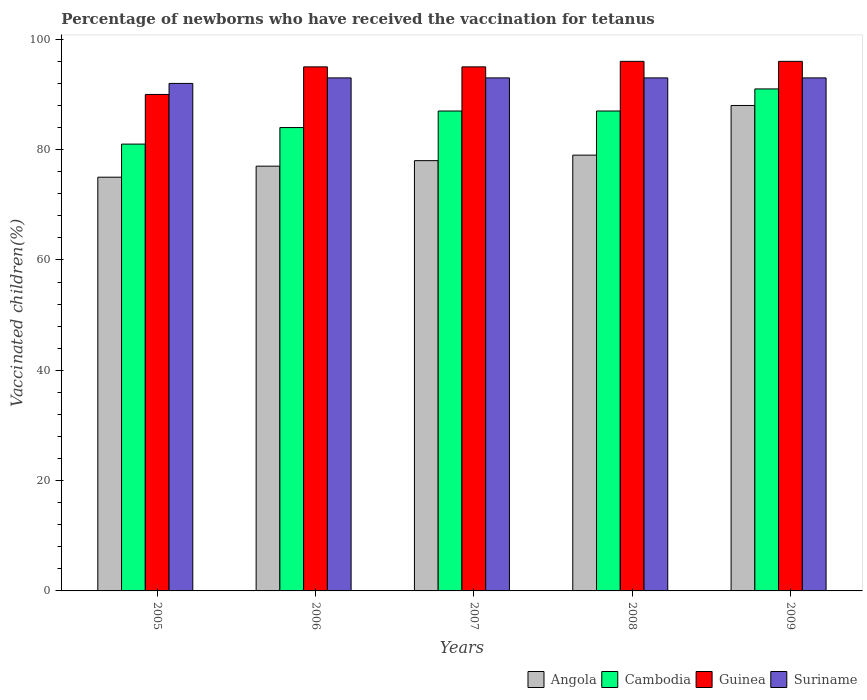Are the number of bars on each tick of the X-axis equal?
Offer a very short reply. Yes. How many bars are there on the 1st tick from the left?
Provide a succinct answer. 4. How many bars are there on the 1st tick from the right?
Offer a very short reply. 4. Across all years, what is the maximum percentage of vaccinated children in Cambodia?
Keep it short and to the point. 91. Across all years, what is the minimum percentage of vaccinated children in Angola?
Your response must be concise. 75. What is the total percentage of vaccinated children in Guinea in the graph?
Provide a short and direct response. 472. What is the difference between the percentage of vaccinated children in Suriname in 2006 and that in 2008?
Provide a short and direct response. 0. What is the average percentage of vaccinated children in Angola per year?
Offer a terse response. 79.4. In how many years, is the percentage of vaccinated children in Angola greater than 68 %?
Keep it short and to the point. 5. What is the ratio of the percentage of vaccinated children in Angola in 2006 to that in 2008?
Offer a very short reply. 0.97. Is the percentage of vaccinated children in Guinea in 2006 less than that in 2007?
Your answer should be very brief. No. Is the difference between the percentage of vaccinated children in Cambodia in 2006 and 2007 greater than the difference between the percentage of vaccinated children in Suriname in 2006 and 2007?
Make the answer very short. No. What is the difference between the highest and the second highest percentage of vaccinated children in Guinea?
Give a very brief answer. 0. Is the sum of the percentage of vaccinated children in Angola in 2005 and 2007 greater than the maximum percentage of vaccinated children in Suriname across all years?
Offer a very short reply. Yes. What does the 1st bar from the left in 2008 represents?
Offer a terse response. Angola. What does the 3rd bar from the right in 2008 represents?
Your response must be concise. Cambodia. Is it the case that in every year, the sum of the percentage of vaccinated children in Cambodia and percentage of vaccinated children in Guinea is greater than the percentage of vaccinated children in Suriname?
Your response must be concise. Yes. How many bars are there?
Provide a short and direct response. 20. Are all the bars in the graph horizontal?
Keep it short and to the point. No. What is the difference between two consecutive major ticks on the Y-axis?
Offer a terse response. 20. Are the values on the major ticks of Y-axis written in scientific E-notation?
Ensure brevity in your answer.  No. Does the graph contain any zero values?
Offer a very short reply. No. How are the legend labels stacked?
Your response must be concise. Horizontal. What is the title of the graph?
Provide a short and direct response. Percentage of newborns who have received the vaccination for tetanus. What is the label or title of the X-axis?
Ensure brevity in your answer.  Years. What is the label or title of the Y-axis?
Give a very brief answer. Vaccinated children(%). What is the Vaccinated children(%) in Cambodia in 2005?
Provide a succinct answer. 81. What is the Vaccinated children(%) in Guinea in 2005?
Offer a terse response. 90. What is the Vaccinated children(%) of Suriname in 2005?
Your answer should be compact. 92. What is the Vaccinated children(%) in Suriname in 2006?
Make the answer very short. 93. What is the Vaccinated children(%) of Angola in 2007?
Make the answer very short. 78. What is the Vaccinated children(%) in Guinea in 2007?
Your answer should be compact. 95. What is the Vaccinated children(%) in Suriname in 2007?
Provide a short and direct response. 93. What is the Vaccinated children(%) in Angola in 2008?
Provide a short and direct response. 79. What is the Vaccinated children(%) in Cambodia in 2008?
Give a very brief answer. 87. What is the Vaccinated children(%) in Guinea in 2008?
Your answer should be compact. 96. What is the Vaccinated children(%) of Suriname in 2008?
Ensure brevity in your answer.  93. What is the Vaccinated children(%) in Cambodia in 2009?
Provide a succinct answer. 91. What is the Vaccinated children(%) of Guinea in 2009?
Your response must be concise. 96. What is the Vaccinated children(%) in Suriname in 2009?
Provide a succinct answer. 93. Across all years, what is the maximum Vaccinated children(%) in Cambodia?
Provide a succinct answer. 91. Across all years, what is the maximum Vaccinated children(%) of Guinea?
Ensure brevity in your answer.  96. Across all years, what is the maximum Vaccinated children(%) of Suriname?
Provide a short and direct response. 93. Across all years, what is the minimum Vaccinated children(%) of Angola?
Provide a short and direct response. 75. Across all years, what is the minimum Vaccinated children(%) in Cambodia?
Give a very brief answer. 81. Across all years, what is the minimum Vaccinated children(%) of Guinea?
Keep it short and to the point. 90. Across all years, what is the minimum Vaccinated children(%) of Suriname?
Offer a terse response. 92. What is the total Vaccinated children(%) in Angola in the graph?
Give a very brief answer. 397. What is the total Vaccinated children(%) of Cambodia in the graph?
Offer a very short reply. 430. What is the total Vaccinated children(%) in Guinea in the graph?
Keep it short and to the point. 472. What is the total Vaccinated children(%) of Suriname in the graph?
Provide a short and direct response. 464. What is the difference between the Vaccinated children(%) in Angola in 2005 and that in 2006?
Your answer should be compact. -2. What is the difference between the Vaccinated children(%) in Cambodia in 2005 and that in 2006?
Your response must be concise. -3. What is the difference between the Vaccinated children(%) of Cambodia in 2005 and that in 2007?
Offer a terse response. -6. What is the difference between the Vaccinated children(%) of Suriname in 2005 and that in 2007?
Make the answer very short. -1. What is the difference between the Vaccinated children(%) of Cambodia in 2005 and that in 2009?
Your answer should be very brief. -10. What is the difference between the Vaccinated children(%) of Suriname in 2005 and that in 2009?
Your answer should be compact. -1. What is the difference between the Vaccinated children(%) of Angola in 2006 and that in 2007?
Your answer should be very brief. -1. What is the difference between the Vaccinated children(%) in Cambodia in 2006 and that in 2007?
Your answer should be compact. -3. What is the difference between the Vaccinated children(%) in Guinea in 2006 and that in 2007?
Keep it short and to the point. 0. What is the difference between the Vaccinated children(%) in Suriname in 2006 and that in 2007?
Ensure brevity in your answer.  0. What is the difference between the Vaccinated children(%) of Angola in 2006 and that in 2008?
Keep it short and to the point. -2. What is the difference between the Vaccinated children(%) of Angola in 2006 and that in 2009?
Keep it short and to the point. -11. What is the difference between the Vaccinated children(%) in Cambodia in 2006 and that in 2009?
Your answer should be very brief. -7. What is the difference between the Vaccinated children(%) of Guinea in 2006 and that in 2009?
Provide a short and direct response. -1. What is the difference between the Vaccinated children(%) of Angola in 2007 and that in 2008?
Ensure brevity in your answer.  -1. What is the difference between the Vaccinated children(%) of Cambodia in 2007 and that in 2009?
Your answer should be very brief. -4. What is the difference between the Vaccinated children(%) of Angola in 2008 and that in 2009?
Offer a very short reply. -9. What is the difference between the Vaccinated children(%) in Cambodia in 2008 and that in 2009?
Provide a succinct answer. -4. What is the difference between the Vaccinated children(%) of Angola in 2005 and the Vaccinated children(%) of Suriname in 2006?
Your response must be concise. -18. What is the difference between the Vaccinated children(%) of Cambodia in 2005 and the Vaccinated children(%) of Suriname in 2006?
Provide a succinct answer. -12. What is the difference between the Vaccinated children(%) of Angola in 2005 and the Vaccinated children(%) of Suriname in 2007?
Provide a succinct answer. -18. What is the difference between the Vaccinated children(%) of Cambodia in 2005 and the Vaccinated children(%) of Guinea in 2007?
Provide a short and direct response. -14. What is the difference between the Vaccinated children(%) of Cambodia in 2005 and the Vaccinated children(%) of Suriname in 2007?
Your answer should be very brief. -12. What is the difference between the Vaccinated children(%) of Guinea in 2005 and the Vaccinated children(%) of Suriname in 2007?
Keep it short and to the point. -3. What is the difference between the Vaccinated children(%) in Angola in 2005 and the Vaccinated children(%) in Guinea in 2008?
Provide a short and direct response. -21. What is the difference between the Vaccinated children(%) of Angola in 2005 and the Vaccinated children(%) of Suriname in 2008?
Make the answer very short. -18. What is the difference between the Vaccinated children(%) in Guinea in 2005 and the Vaccinated children(%) in Suriname in 2008?
Your answer should be compact. -3. What is the difference between the Vaccinated children(%) in Angola in 2005 and the Vaccinated children(%) in Cambodia in 2009?
Your response must be concise. -16. What is the difference between the Vaccinated children(%) of Cambodia in 2005 and the Vaccinated children(%) of Suriname in 2009?
Your answer should be compact. -12. What is the difference between the Vaccinated children(%) in Angola in 2006 and the Vaccinated children(%) in Guinea in 2007?
Your response must be concise. -18. What is the difference between the Vaccinated children(%) of Angola in 2006 and the Vaccinated children(%) of Suriname in 2007?
Your answer should be very brief. -16. What is the difference between the Vaccinated children(%) in Cambodia in 2006 and the Vaccinated children(%) in Guinea in 2007?
Provide a short and direct response. -11. What is the difference between the Vaccinated children(%) of Guinea in 2006 and the Vaccinated children(%) of Suriname in 2007?
Your answer should be very brief. 2. What is the difference between the Vaccinated children(%) of Angola in 2006 and the Vaccinated children(%) of Guinea in 2008?
Provide a succinct answer. -19. What is the difference between the Vaccinated children(%) of Cambodia in 2006 and the Vaccinated children(%) of Guinea in 2008?
Make the answer very short. -12. What is the difference between the Vaccinated children(%) of Angola in 2006 and the Vaccinated children(%) of Cambodia in 2009?
Provide a succinct answer. -14. What is the difference between the Vaccinated children(%) of Angola in 2006 and the Vaccinated children(%) of Suriname in 2009?
Keep it short and to the point. -16. What is the difference between the Vaccinated children(%) of Cambodia in 2006 and the Vaccinated children(%) of Guinea in 2009?
Ensure brevity in your answer.  -12. What is the difference between the Vaccinated children(%) in Guinea in 2006 and the Vaccinated children(%) in Suriname in 2009?
Offer a terse response. 2. What is the difference between the Vaccinated children(%) of Angola in 2007 and the Vaccinated children(%) of Suriname in 2008?
Keep it short and to the point. -15. What is the difference between the Vaccinated children(%) of Cambodia in 2007 and the Vaccinated children(%) of Guinea in 2008?
Offer a very short reply. -9. What is the difference between the Vaccinated children(%) of Angola in 2007 and the Vaccinated children(%) of Suriname in 2009?
Ensure brevity in your answer.  -15. What is the difference between the Vaccinated children(%) of Cambodia in 2007 and the Vaccinated children(%) of Suriname in 2009?
Your answer should be very brief. -6. What is the difference between the Vaccinated children(%) of Angola in 2008 and the Vaccinated children(%) of Cambodia in 2009?
Offer a very short reply. -12. What is the difference between the Vaccinated children(%) of Angola in 2008 and the Vaccinated children(%) of Guinea in 2009?
Give a very brief answer. -17. What is the difference between the Vaccinated children(%) of Angola in 2008 and the Vaccinated children(%) of Suriname in 2009?
Offer a very short reply. -14. What is the difference between the Vaccinated children(%) in Cambodia in 2008 and the Vaccinated children(%) in Suriname in 2009?
Offer a terse response. -6. What is the difference between the Vaccinated children(%) in Guinea in 2008 and the Vaccinated children(%) in Suriname in 2009?
Ensure brevity in your answer.  3. What is the average Vaccinated children(%) of Angola per year?
Make the answer very short. 79.4. What is the average Vaccinated children(%) of Cambodia per year?
Offer a very short reply. 86. What is the average Vaccinated children(%) in Guinea per year?
Make the answer very short. 94.4. What is the average Vaccinated children(%) of Suriname per year?
Provide a succinct answer. 92.8. In the year 2005, what is the difference between the Vaccinated children(%) of Angola and Vaccinated children(%) of Suriname?
Your answer should be very brief. -17. In the year 2005, what is the difference between the Vaccinated children(%) of Cambodia and Vaccinated children(%) of Suriname?
Make the answer very short. -11. In the year 2006, what is the difference between the Vaccinated children(%) of Angola and Vaccinated children(%) of Guinea?
Provide a short and direct response. -18. In the year 2006, what is the difference between the Vaccinated children(%) of Cambodia and Vaccinated children(%) of Guinea?
Provide a succinct answer. -11. In the year 2007, what is the difference between the Vaccinated children(%) of Angola and Vaccinated children(%) of Cambodia?
Provide a succinct answer. -9. In the year 2007, what is the difference between the Vaccinated children(%) of Angola and Vaccinated children(%) of Guinea?
Ensure brevity in your answer.  -17. In the year 2007, what is the difference between the Vaccinated children(%) in Cambodia and Vaccinated children(%) in Suriname?
Keep it short and to the point. -6. In the year 2008, what is the difference between the Vaccinated children(%) in Angola and Vaccinated children(%) in Cambodia?
Ensure brevity in your answer.  -8. In the year 2008, what is the difference between the Vaccinated children(%) in Angola and Vaccinated children(%) in Guinea?
Your response must be concise. -17. In the year 2008, what is the difference between the Vaccinated children(%) of Cambodia and Vaccinated children(%) of Suriname?
Make the answer very short. -6. In the year 2009, what is the difference between the Vaccinated children(%) of Angola and Vaccinated children(%) of Guinea?
Give a very brief answer. -8. In the year 2009, what is the difference between the Vaccinated children(%) in Angola and Vaccinated children(%) in Suriname?
Your response must be concise. -5. In the year 2009, what is the difference between the Vaccinated children(%) in Cambodia and Vaccinated children(%) in Suriname?
Give a very brief answer. -2. What is the ratio of the Vaccinated children(%) of Angola in 2005 to that in 2006?
Give a very brief answer. 0.97. What is the ratio of the Vaccinated children(%) of Cambodia in 2005 to that in 2006?
Keep it short and to the point. 0.96. What is the ratio of the Vaccinated children(%) in Angola in 2005 to that in 2007?
Offer a terse response. 0.96. What is the ratio of the Vaccinated children(%) of Cambodia in 2005 to that in 2007?
Offer a very short reply. 0.93. What is the ratio of the Vaccinated children(%) of Guinea in 2005 to that in 2007?
Provide a short and direct response. 0.95. What is the ratio of the Vaccinated children(%) of Angola in 2005 to that in 2008?
Give a very brief answer. 0.95. What is the ratio of the Vaccinated children(%) in Guinea in 2005 to that in 2008?
Provide a succinct answer. 0.94. What is the ratio of the Vaccinated children(%) in Suriname in 2005 to that in 2008?
Make the answer very short. 0.99. What is the ratio of the Vaccinated children(%) in Angola in 2005 to that in 2009?
Give a very brief answer. 0.85. What is the ratio of the Vaccinated children(%) in Cambodia in 2005 to that in 2009?
Provide a succinct answer. 0.89. What is the ratio of the Vaccinated children(%) of Guinea in 2005 to that in 2009?
Make the answer very short. 0.94. What is the ratio of the Vaccinated children(%) of Suriname in 2005 to that in 2009?
Keep it short and to the point. 0.99. What is the ratio of the Vaccinated children(%) of Angola in 2006 to that in 2007?
Keep it short and to the point. 0.99. What is the ratio of the Vaccinated children(%) of Cambodia in 2006 to that in 2007?
Offer a very short reply. 0.97. What is the ratio of the Vaccinated children(%) of Angola in 2006 to that in 2008?
Your response must be concise. 0.97. What is the ratio of the Vaccinated children(%) of Cambodia in 2006 to that in 2008?
Your answer should be compact. 0.97. What is the ratio of the Vaccinated children(%) of Guinea in 2006 to that in 2008?
Give a very brief answer. 0.99. What is the ratio of the Vaccinated children(%) of Angola in 2006 to that in 2009?
Your response must be concise. 0.88. What is the ratio of the Vaccinated children(%) of Cambodia in 2006 to that in 2009?
Your answer should be very brief. 0.92. What is the ratio of the Vaccinated children(%) of Guinea in 2006 to that in 2009?
Offer a very short reply. 0.99. What is the ratio of the Vaccinated children(%) in Angola in 2007 to that in 2008?
Provide a succinct answer. 0.99. What is the ratio of the Vaccinated children(%) of Cambodia in 2007 to that in 2008?
Your answer should be compact. 1. What is the ratio of the Vaccinated children(%) in Guinea in 2007 to that in 2008?
Offer a terse response. 0.99. What is the ratio of the Vaccinated children(%) in Angola in 2007 to that in 2009?
Offer a terse response. 0.89. What is the ratio of the Vaccinated children(%) of Cambodia in 2007 to that in 2009?
Make the answer very short. 0.96. What is the ratio of the Vaccinated children(%) in Angola in 2008 to that in 2009?
Make the answer very short. 0.9. What is the ratio of the Vaccinated children(%) of Cambodia in 2008 to that in 2009?
Your response must be concise. 0.96. What is the difference between the highest and the second highest Vaccinated children(%) of Guinea?
Keep it short and to the point. 0. What is the difference between the highest and the lowest Vaccinated children(%) of Angola?
Your response must be concise. 13. 